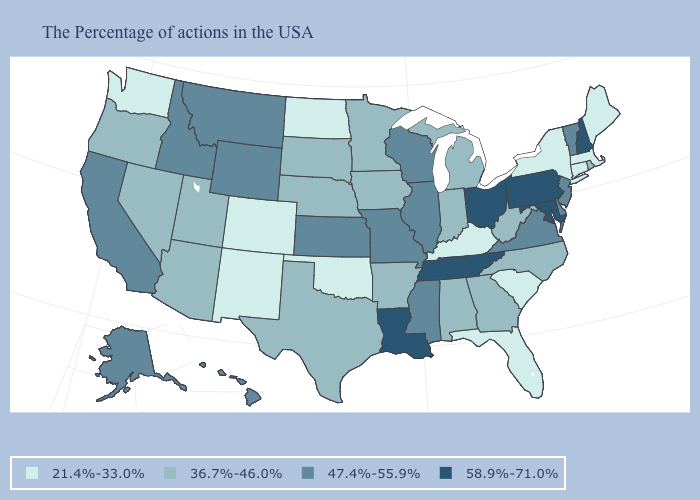Name the states that have a value in the range 47.4%-55.9%?
Give a very brief answer. Vermont, New Jersey, Delaware, Virginia, Wisconsin, Illinois, Mississippi, Missouri, Kansas, Wyoming, Montana, Idaho, California, Alaska, Hawaii. What is the value of Maryland?
Give a very brief answer. 58.9%-71.0%. Does Oregon have a lower value than Maine?
Keep it brief. No. What is the value of Alaska?
Write a very short answer. 47.4%-55.9%. Does Delaware have the same value as Virginia?
Give a very brief answer. Yes. What is the value of Oregon?
Give a very brief answer. 36.7%-46.0%. Does Indiana have the lowest value in the MidWest?
Answer briefly. No. How many symbols are there in the legend?
Concise answer only. 4. Does North Dakota have the lowest value in the USA?
Keep it brief. Yes. Does Virginia have the lowest value in the South?
Be succinct. No. Name the states that have a value in the range 47.4%-55.9%?
Short answer required. Vermont, New Jersey, Delaware, Virginia, Wisconsin, Illinois, Mississippi, Missouri, Kansas, Wyoming, Montana, Idaho, California, Alaska, Hawaii. What is the value of Oklahoma?
Write a very short answer. 21.4%-33.0%. Does Colorado have the lowest value in the West?
Write a very short answer. Yes. Does New Mexico have the highest value in the West?
Short answer required. No. 